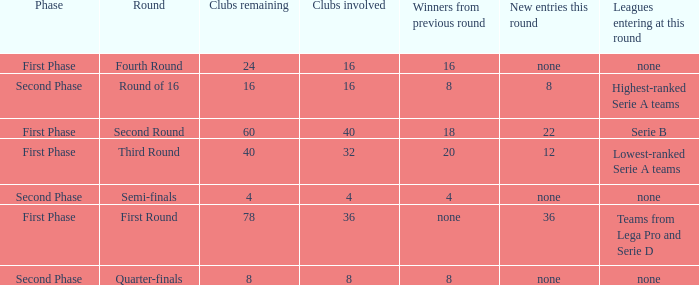From the round name of third round; what would the new entries this round that would be found? 12.0. 